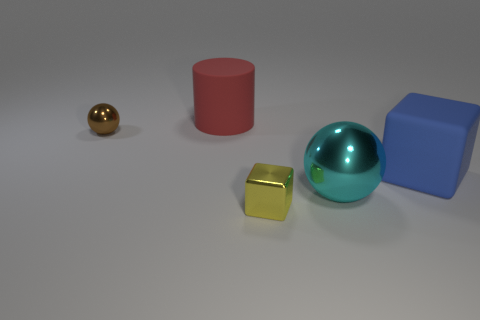Add 5 cyan rubber blocks. How many objects exist? 10 Subtract all cylinders. How many objects are left? 4 Add 3 large red rubber objects. How many large red rubber objects are left? 4 Add 2 red matte blocks. How many red matte blocks exist? 2 Subtract 0 green cylinders. How many objects are left? 5 Subtract all tiny brown metal spheres. Subtract all yellow objects. How many objects are left? 3 